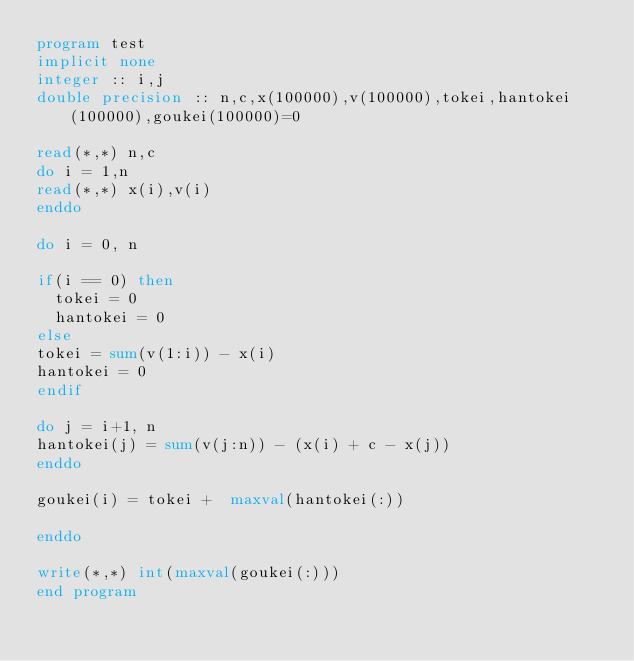<code> <loc_0><loc_0><loc_500><loc_500><_FORTRAN_>program test
implicit none
integer :: i,j
double precision :: n,c,x(100000),v(100000),tokei,hantokei(100000),goukei(100000)=0

read(*,*) n,c
do i = 1,n
read(*,*) x(i),v(i)
enddo

do i = 0, n

if(i == 0) then
  tokei = 0
  hantokei = 0
else
tokei = sum(v(1:i)) - x(i)
hantokei = 0
endif

do j = i+1, n
hantokei(j) = sum(v(j:n)) - (x(i) + c - x(j))
enddo

goukei(i) = tokei +  maxval(hantokei(:))

enddo

write(*,*) int(maxval(goukei(:)))
end program</code> 